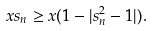Convert formula to latex. <formula><loc_0><loc_0><loc_500><loc_500>x s _ { n } \geq x ( 1 - | s _ { n } ^ { 2 } - 1 | ) .</formula> 